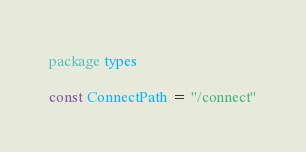<code> <loc_0><loc_0><loc_500><loc_500><_Go_>package types

const ConnectPath = "/connect"
</code> 